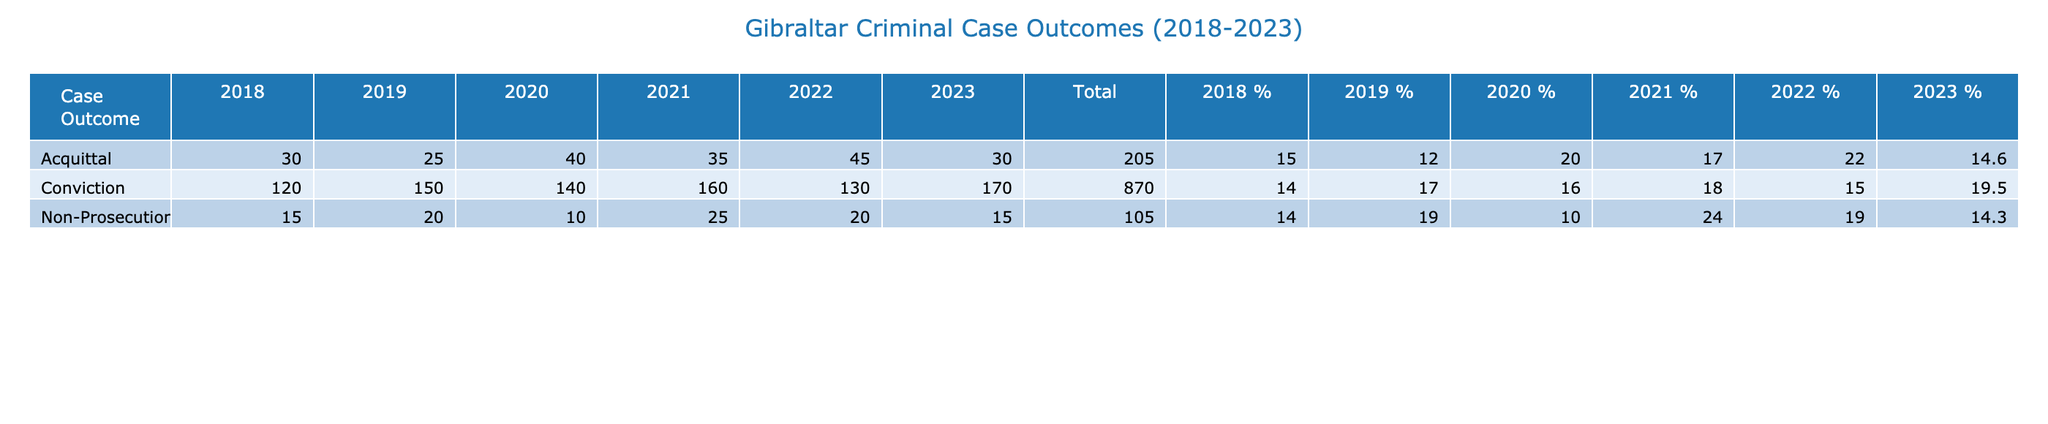What was the total number of convictions in 2020? In 2020, the table shows that there were 140 convictions. Therefore, the total number of convictions in that year is directly stated as 140.
Answer: 140 Which year had the highest number of acquittals, and what was that number? By looking at the acquittals row across the years, we see that the highest number occurred in 2022 with a total of 45 acquittals.
Answer: 2022, 45 What is the total number of non-prosecution cases from 2018 to 2023? To find the total number of non-prosecution cases from 2018 to 2023, we can sum the counts: 15 (2018) + 20 (2019) + 10 (2020) + 25 (2021) + 20 (2022) + 15 (2023) = 105.
Answer: 105 Did the number of convictions increase every year from 2018 to 2023? By examining the conviction counts: 120 (2018), 150 (2019), 140 (2020), 160 (2021), 130 (2022), and 170 (2023), we see that the count dropped from 2019 to 2020 and from 2021 to 2022. Therefore, the number did not increase every year.
Answer: No What was the percentage of acquittals in 2021 compared to the total case outcomes for that year? First, we sum the case outcomes for 2021: 160 (Conviction) + 35 (Acquittal) + 25 (Non-Prosecution) = 220. The acquittals in 2021 were 35. The percentage of acquittals is (35/220) * 100 = 15.9%.
Answer: 15.9% 